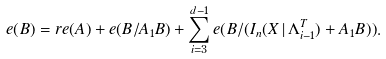<formula> <loc_0><loc_0><loc_500><loc_500>e ( B ) = r e ( A ) + e ( B / A _ { 1 } B ) + \sum _ { i = 3 } ^ { d - 1 } e ( B / ( I _ { n } ( X \, | \, \Lambda _ { i - 1 } ^ { T } ) + A _ { 1 } B ) ) .</formula> 